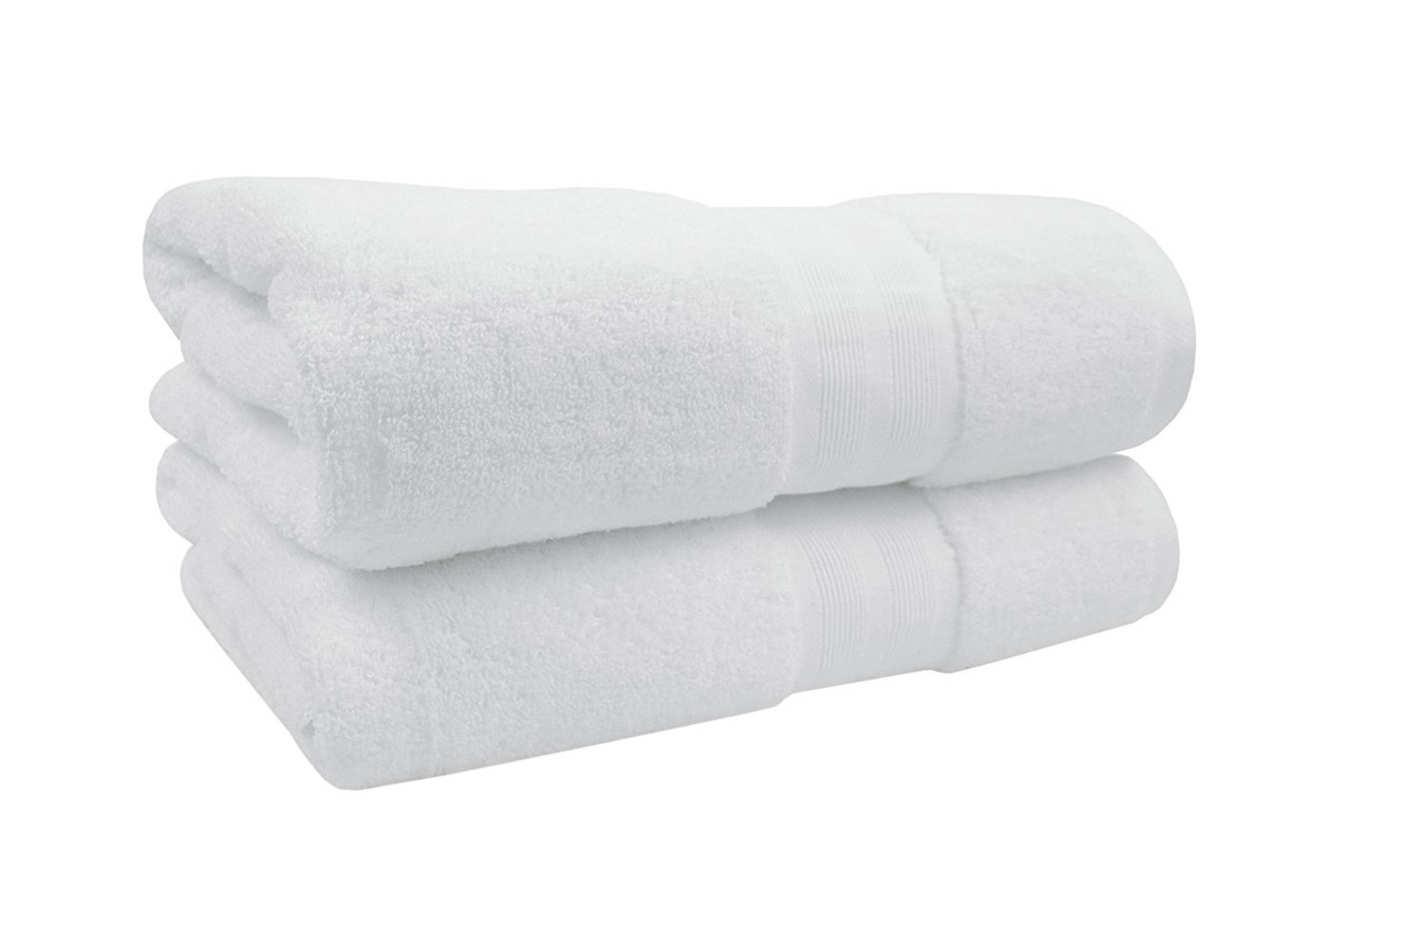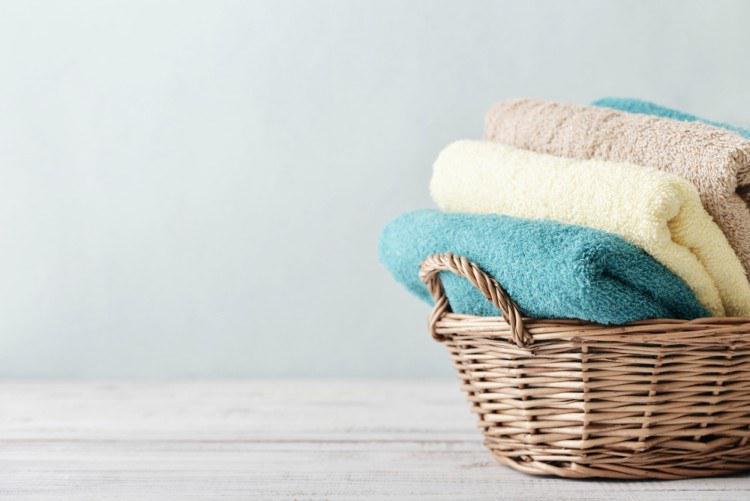The first image is the image on the left, the second image is the image on the right. Considering the images on both sides, is "Exactly two large white folded towels are shown in one image." valid? Answer yes or no. Yes. The first image is the image on the left, the second image is the image on the right. Examine the images to the left and right. Is the description "There are at most 6 towels shown." accurate? Answer yes or no. Yes. 